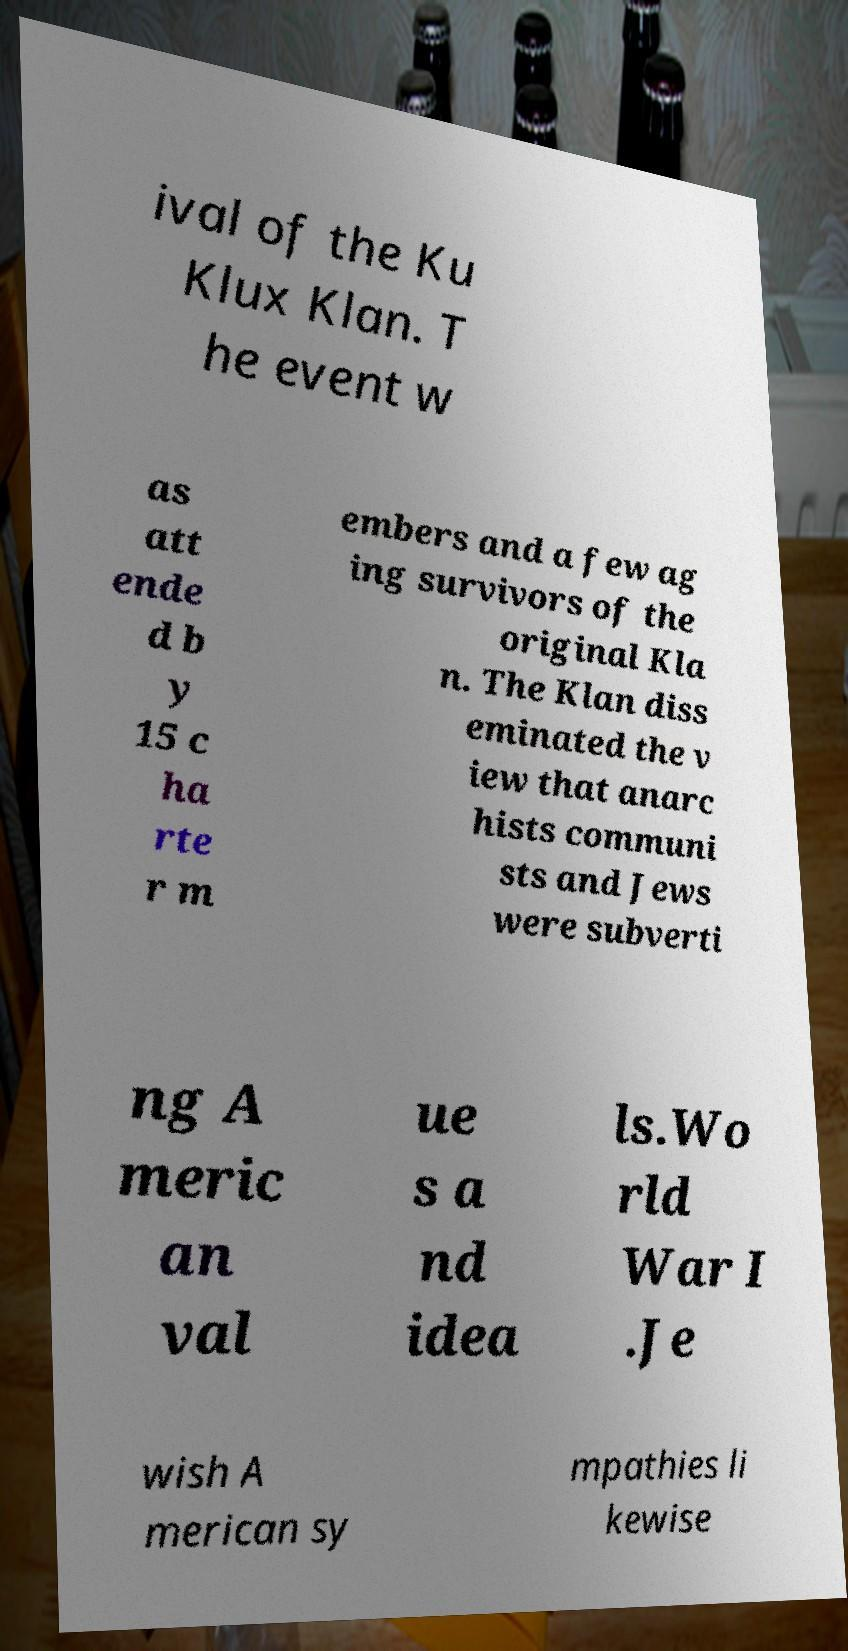Please identify and transcribe the text found in this image. ival of the Ku Klux Klan. T he event w as att ende d b y 15 c ha rte r m embers and a few ag ing survivors of the original Kla n. The Klan diss eminated the v iew that anarc hists communi sts and Jews were subverti ng A meric an val ue s a nd idea ls.Wo rld War I .Je wish A merican sy mpathies li kewise 